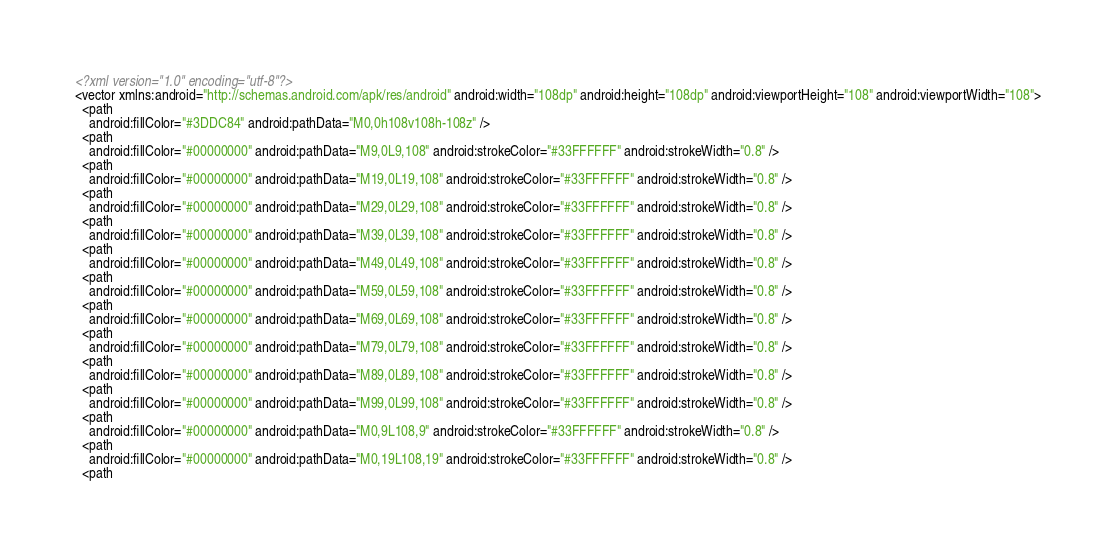<code> <loc_0><loc_0><loc_500><loc_500><_XML_><?xml version="1.0" encoding="utf-8"?>
<vector xmlns:android="http://schemas.android.com/apk/res/android" android:width="108dp" android:height="108dp" android:viewportHeight="108" android:viewportWidth="108">
  <path
    android:fillColor="#3DDC84" android:pathData="M0,0h108v108h-108z" />
  <path
    android:fillColor="#00000000" android:pathData="M9,0L9,108" android:strokeColor="#33FFFFFF" android:strokeWidth="0.8" />
  <path
    android:fillColor="#00000000" android:pathData="M19,0L19,108" android:strokeColor="#33FFFFFF" android:strokeWidth="0.8" />
  <path
    android:fillColor="#00000000" android:pathData="M29,0L29,108" android:strokeColor="#33FFFFFF" android:strokeWidth="0.8" />
  <path
    android:fillColor="#00000000" android:pathData="M39,0L39,108" android:strokeColor="#33FFFFFF" android:strokeWidth="0.8" />
  <path
    android:fillColor="#00000000" android:pathData="M49,0L49,108" android:strokeColor="#33FFFFFF" android:strokeWidth="0.8" />
  <path
    android:fillColor="#00000000" android:pathData="M59,0L59,108" android:strokeColor="#33FFFFFF" android:strokeWidth="0.8" />
  <path
    android:fillColor="#00000000" android:pathData="M69,0L69,108" android:strokeColor="#33FFFFFF" android:strokeWidth="0.8" />
  <path
    android:fillColor="#00000000" android:pathData="M79,0L79,108" android:strokeColor="#33FFFFFF" android:strokeWidth="0.8" />
  <path
    android:fillColor="#00000000" android:pathData="M89,0L89,108" android:strokeColor="#33FFFFFF" android:strokeWidth="0.8" />
  <path
    android:fillColor="#00000000" android:pathData="M99,0L99,108" android:strokeColor="#33FFFFFF" android:strokeWidth="0.8" />
  <path
    android:fillColor="#00000000" android:pathData="M0,9L108,9" android:strokeColor="#33FFFFFF" android:strokeWidth="0.8" />
  <path
    android:fillColor="#00000000" android:pathData="M0,19L108,19" android:strokeColor="#33FFFFFF" android:strokeWidth="0.8" />
  <path</code> 